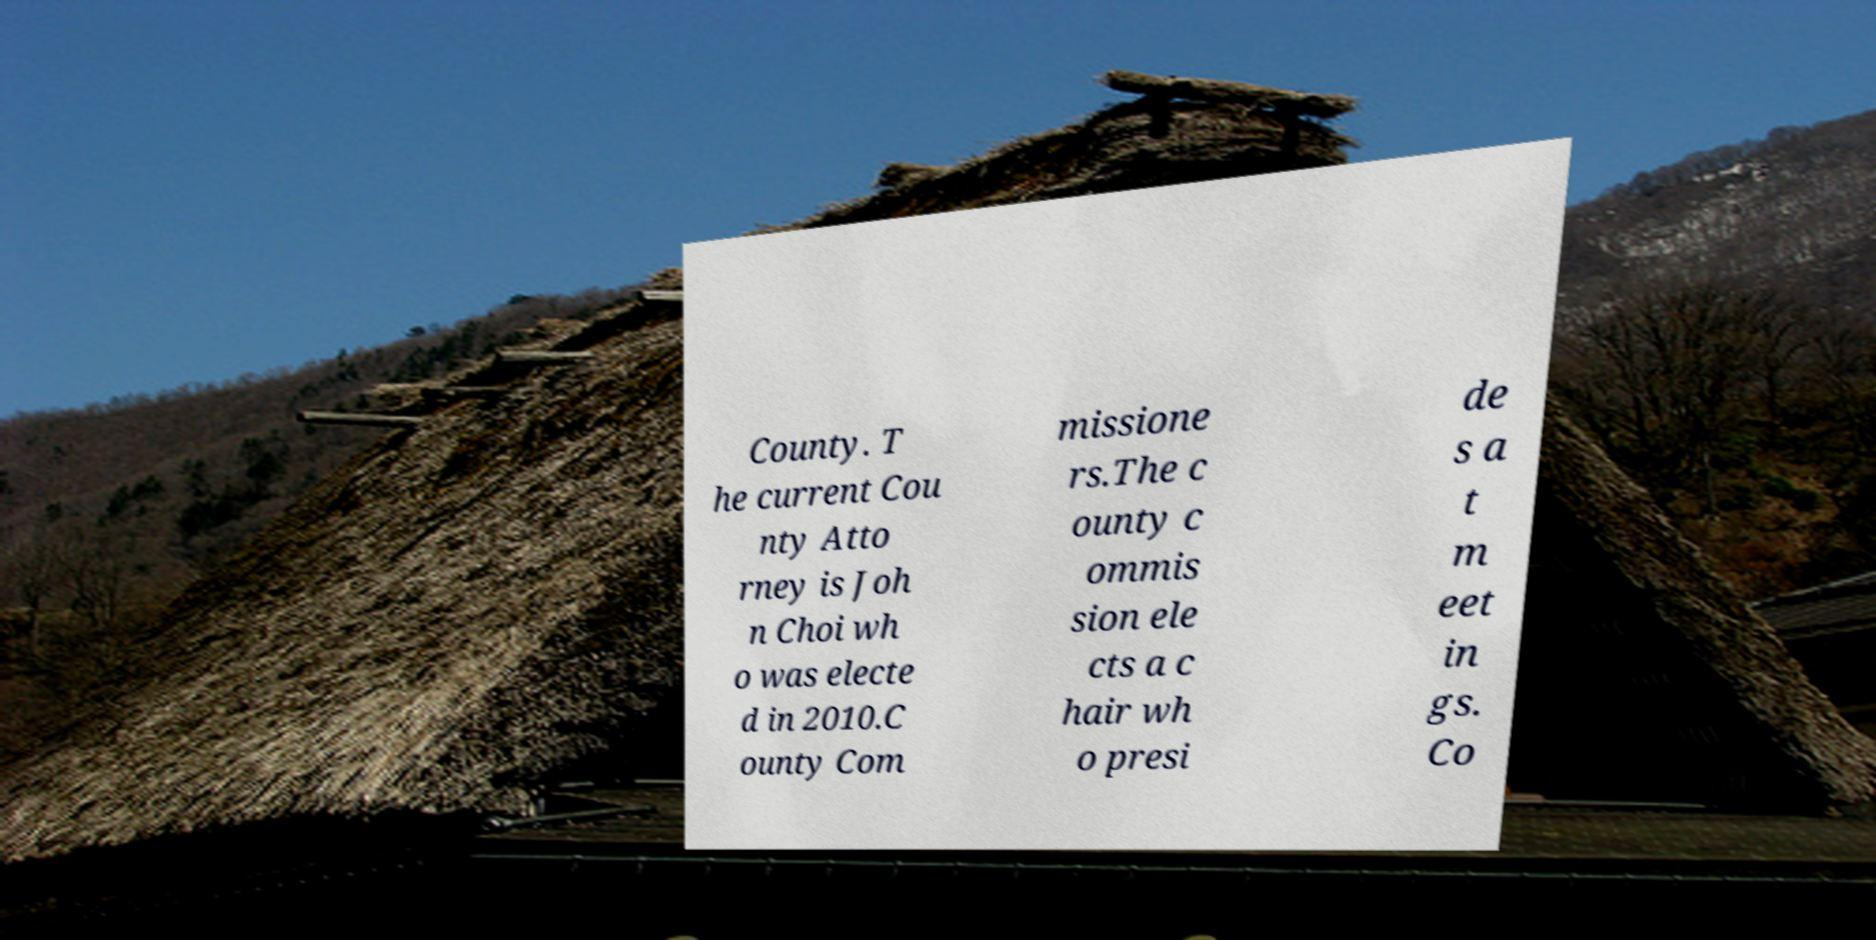Can you read and provide the text displayed in the image?This photo seems to have some interesting text. Can you extract and type it out for me? County. T he current Cou nty Atto rney is Joh n Choi wh o was electe d in 2010.C ounty Com missione rs.The c ounty c ommis sion ele cts a c hair wh o presi de s a t m eet in gs. Co 